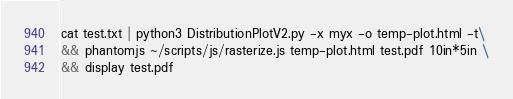<code> <loc_0><loc_0><loc_500><loc_500><_Bash_>
cat test.txt | python3 DistributionPlotV2.py -x myx -o temp-plot.html -t\
&& phantomjs ~/scripts/js/rasterize.js temp-plot.html test.pdf 10in*5in \
&& display test.pdf
</code> 